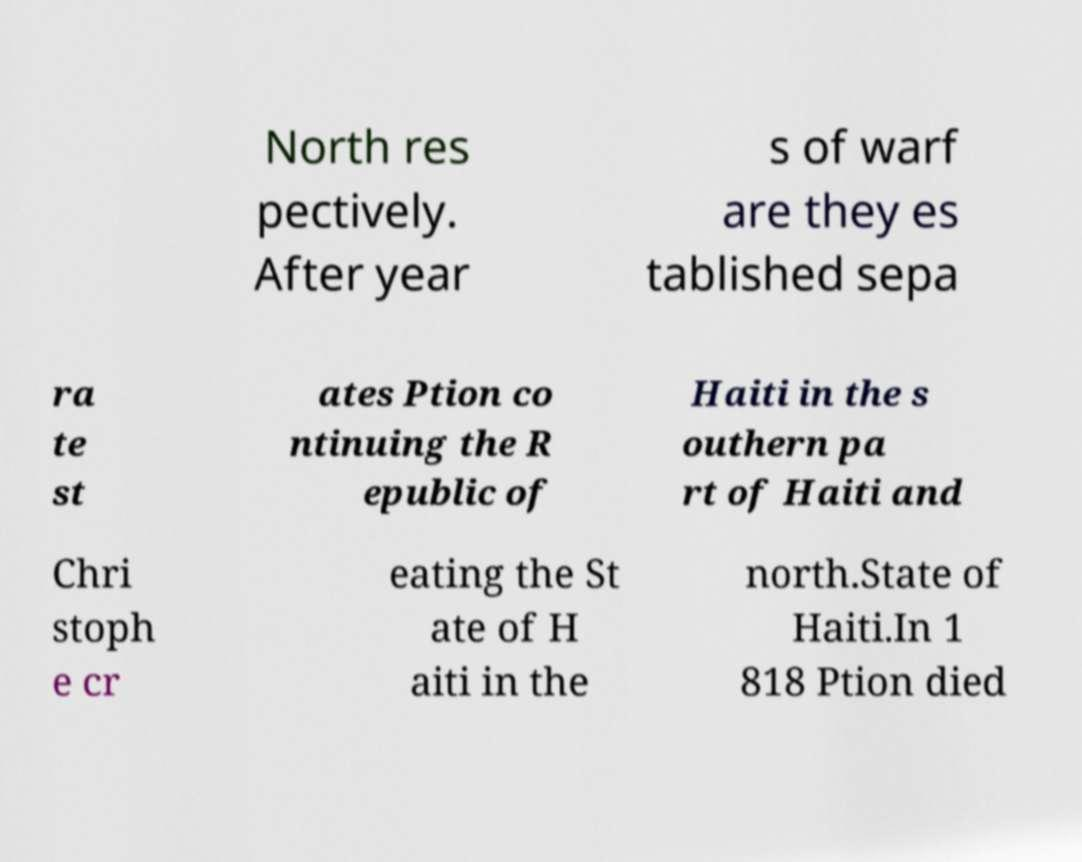Please read and relay the text visible in this image. What does it say? North res pectively. After year s of warf are they es tablished sepa ra te st ates Ption co ntinuing the R epublic of Haiti in the s outhern pa rt of Haiti and Chri stoph e cr eating the St ate of H aiti in the north.State of Haiti.In 1 818 Ption died 